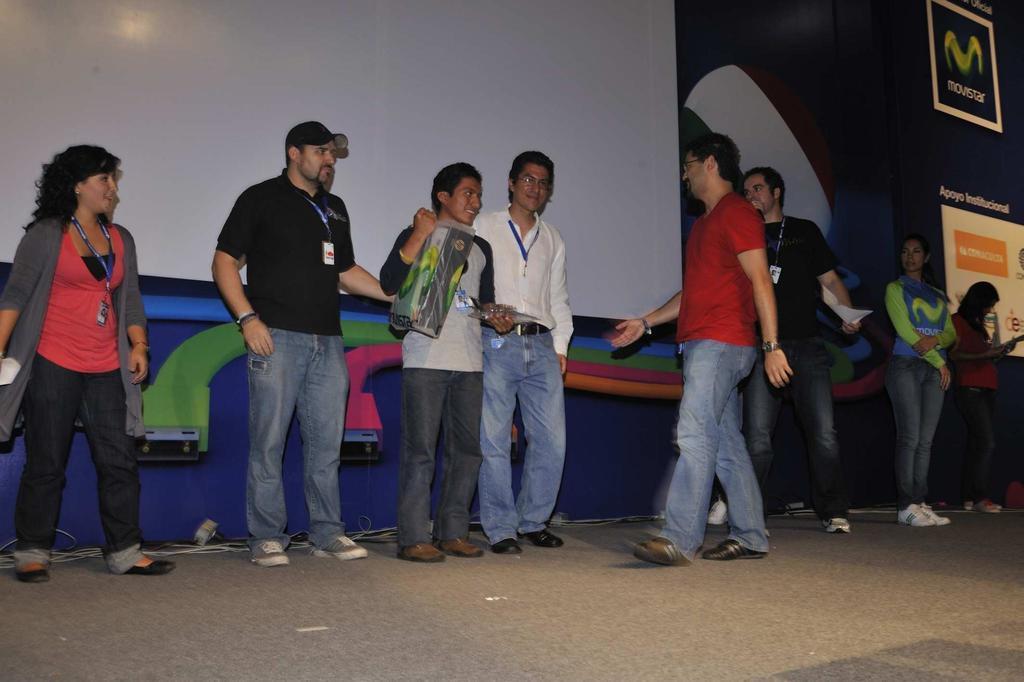Please provide a concise description of this image. In this picture we can see some people are standing, a man in the middle is holding a box, on the left side there is a projector screen, on the right side we can see hoarding, there is some text on these hoardings. 